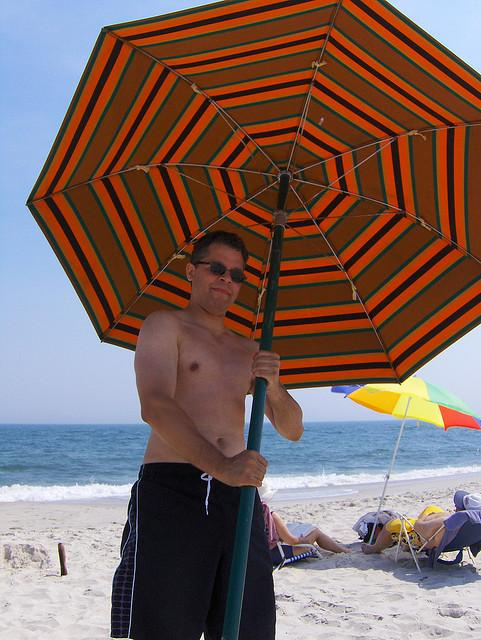If he is going to step out from under this structure he should put on what? sunscreen 